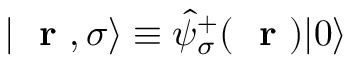<formula> <loc_0><loc_0><loc_500><loc_500>| r , \sigma \rangle \equiv \hat { \psi } _ { \sigma } ^ { + } ( r ) | 0 \rangle</formula> 